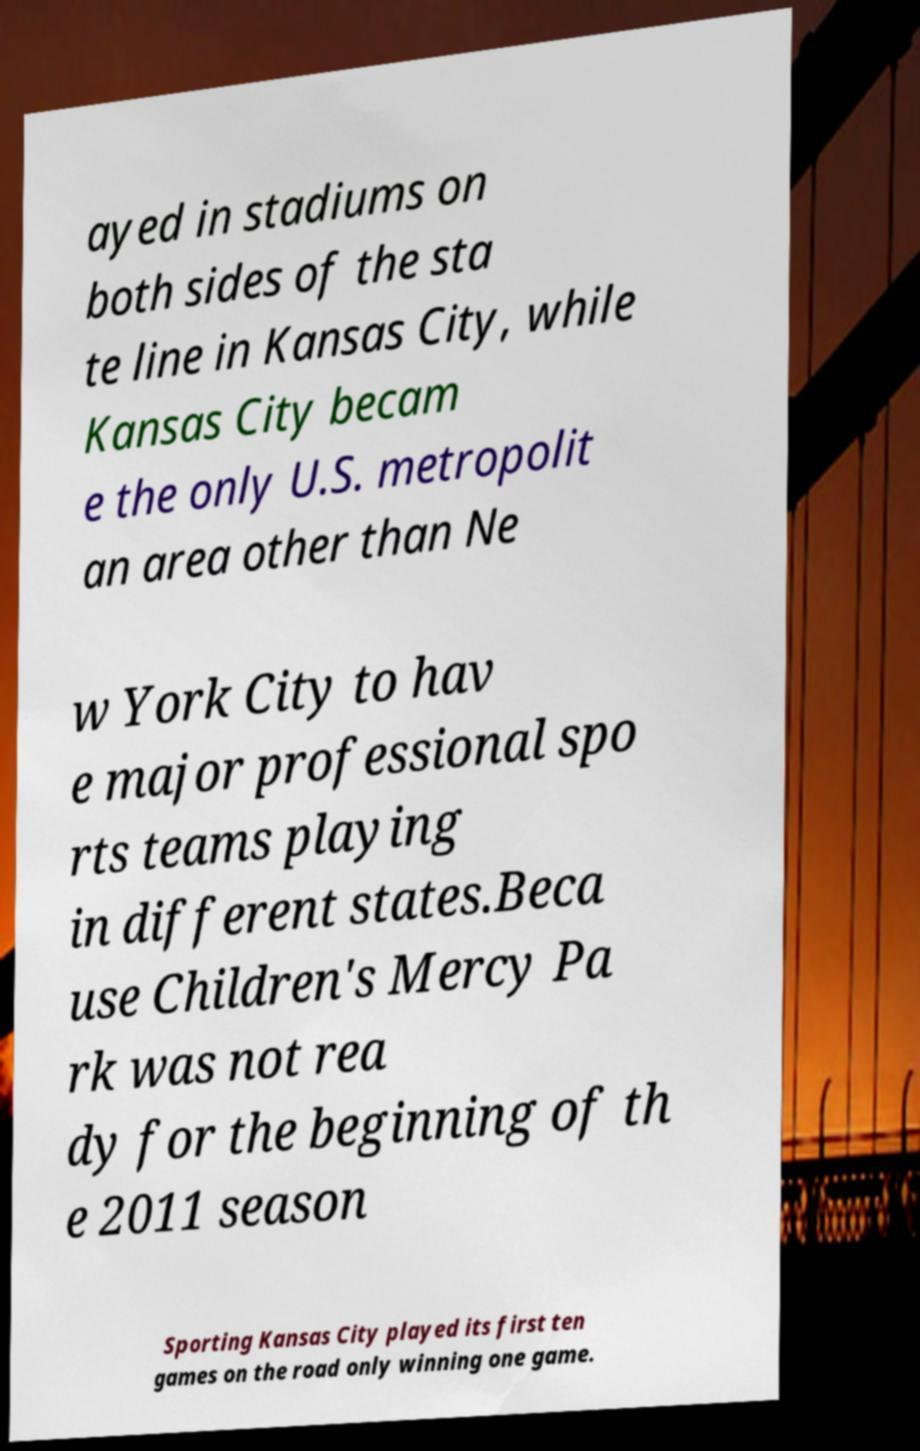Please identify and transcribe the text found in this image. ayed in stadiums on both sides of the sta te line in Kansas City, while Kansas City becam e the only U.S. metropolit an area other than Ne w York City to hav e major professional spo rts teams playing in different states.Beca use Children's Mercy Pa rk was not rea dy for the beginning of th e 2011 season Sporting Kansas City played its first ten games on the road only winning one game. 